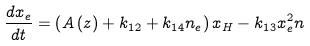Convert formula to latex. <formula><loc_0><loc_0><loc_500><loc_500>\frac { d x _ { e } } { d t } = \left ( A \left ( z \right ) + k _ { 1 2 } + k _ { 1 4 } n _ { e } \right ) x _ { H } - k _ { 1 3 } x _ { e } ^ { 2 } n</formula> 